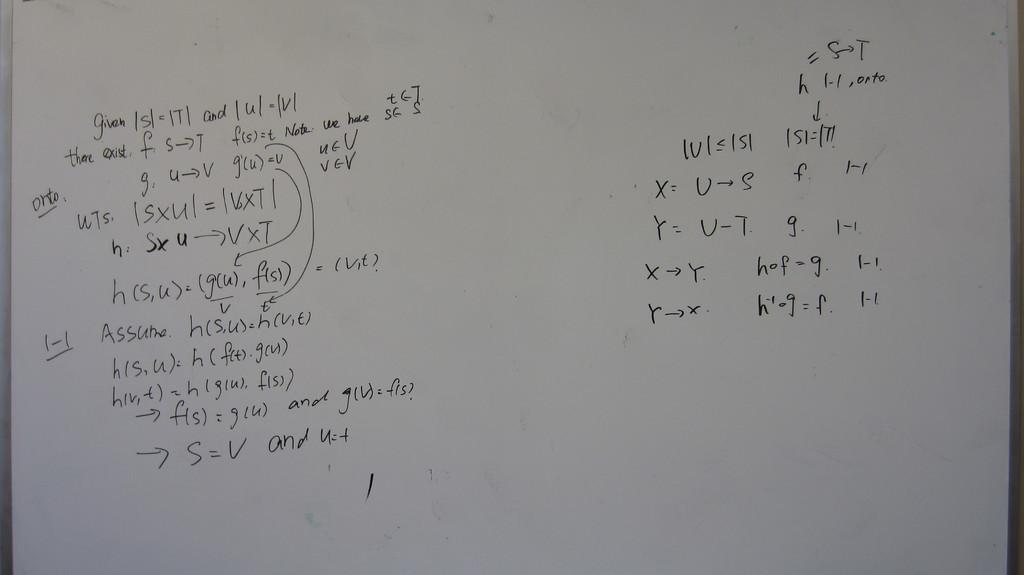<image>
Write a terse but informative summary of the picture. A whiteboard is covered with math derivation starting with the "given" information. 